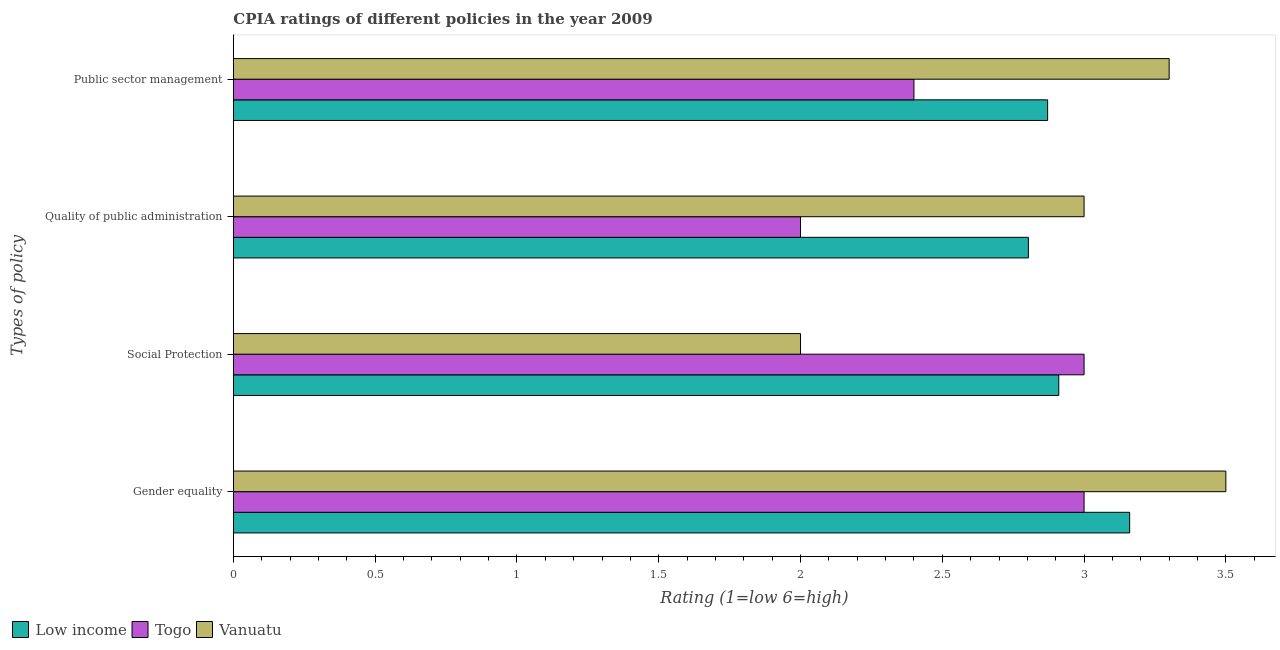How many different coloured bars are there?
Provide a short and direct response. 3. How many groups of bars are there?
Offer a terse response. 4. How many bars are there on the 3rd tick from the top?
Your answer should be very brief. 3. What is the label of the 3rd group of bars from the top?
Your response must be concise. Social Protection. What is the cpia rating of social protection in Vanuatu?
Give a very brief answer. 2. Across all countries, what is the maximum cpia rating of gender equality?
Offer a very short reply. 3.5. Across all countries, what is the minimum cpia rating of public sector management?
Your answer should be compact. 2.4. In which country was the cpia rating of social protection maximum?
Provide a short and direct response. Togo. In which country was the cpia rating of social protection minimum?
Give a very brief answer. Vanuatu. What is the total cpia rating of social protection in the graph?
Provide a short and direct response. 7.91. What is the difference between the cpia rating of gender equality in Low income and that in Togo?
Your answer should be compact. 0.16. What is the difference between the cpia rating of public sector management in Vanuatu and the cpia rating of quality of public administration in Low income?
Give a very brief answer. 0.5. What is the average cpia rating of quality of public administration per country?
Offer a very short reply. 2.6. What is the difference between the cpia rating of quality of public administration and cpia rating of gender equality in Low income?
Make the answer very short. -0.36. What is the ratio of the cpia rating of quality of public administration in Vanuatu to that in Togo?
Offer a very short reply. 1.5. Is the difference between the cpia rating of gender equality in Vanuatu and Low income greater than the difference between the cpia rating of public sector management in Vanuatu and Low income?
Provide a succinct answer. No. What is the difference between the highest and the second highest cpia rating of gender equality?
Your answer should be compact. 0.34. In how many countries, is the cpia rating of public sector management greater than the average cpia rating of public sector management taken over all countries?
Your answer should be compact. 2. What does the 1st bar from the top in Quality of public administration represents?
Offer a very short reply. Vanuatu. What does the 1st bar from the bottom in Public sector management represents?
Ensure brevity in your answer.  Low income. How many bars are there?
Make the answer very short. 12. How many countries are there in the graph?
Your response must be concise. 3. Does the graph contain any zero values?
Offer a terse response. No. How are the legend labels stacked?
Your answer should be compact. Horizontal. What is the title of the graph?
Provide a succinct answer. CPIA ratings of different policies in the year 2009. Does "Turks and Caicos Islands" appear as one of the legend labels in the graph?
Provide a succinct answer. No. What is the label or title of the X-axis?
Keep it short and to the point. Rating (1=low 6=high). What is the label or title of the Y-axis?
Your response must be concise. Types of policy. What is the Rating (1=low 6=high) in Low income in Gender equality?
Your answer should be compact. 3.16. What is the Rating (1=low 6=high) of Vanuatu in Gender equality?
Keep it short and to the point. 3.5. What is the Rating (1=low 6=high) of Low income in Social Protection?
Keep it short and to the point. 2.91. What is the Rating (1=low 6=high) in Togo in Social Protection?
Ensure brevity in your answer.  3. What is the Rating (1=low 6=high) in Low income in Quality of public administration?
Provide a succinct answer. 2.8. What is the Rating (1=low 6=high) of Togo in Quality of public administration?
Give a very brief answer. 2. What is the Rating (1=low 6=high) of Low income in Public sector management?
Keep it short and to the point. 2.87. What is the Rating (1=low 6=high) in Togo in Public sector management?
Offer a terse response. 2.4. Across all Types of policy, what is the maximum Rating (1=low 6=high) in Low income?
Provide a short and direct response. 3.16. Across all Types of policy, what is the maximum Rating (1=low 6=high) of Vanuatu?
Your answer should be very brief. 3.5. Across all Types of policy, what is the minimum Rating (1=low 6=high) in Low income?
Provide a succinct answer. 2.8. Across all Types of policy, what is the minimum Rating (1=low 6=high) in Togo?
Your answer should be very brief. 2. Across all Types of policy, what is the minimum Rating (1=low 6=high) of Vanuatu?
Offer a terse response. 2. What is the total Rating (1=low 6=high) of Low income in the graph?
Your answer should be compact. 11.75. What is the total Rating (1=low 6=high) in Togo in the graph?
Offer a very short reply. 10.4. What is the total Rating (1=low 6=high) in Vanuatu in the graph?
Give a very brief answer. 11.8. What is the difference between the Rating (1=low 6=high) in Low income in Gender equality and that in Social Protection?
Keep it short and to the point. 0.25. What is the difference between the Rating (1=low 6=high) of Low income in Gender equality and that in Quality of public administration?
Give a very brief answer. 0.36. What is the difference between the Rating (1=low 6=high) of Togo in Gender equality and that in Quality of public administration?
Give a very brief answer. 1. What is the difference between the Rating (1=low 6=high) of Vanuatu in Gender equality and that in Quality of public administration?
Your answer should be compact. 0.5. What is the difference between the Rating (1=low 6=high) in Low income in Gender equality and that in Public sector management?
Give a very brief answer. 0.29. What is the difference between the Rating (1=low 6=high) in Togo in Gender equality and that in Public sector management?
Provide a short and direct response. 0.6. What is the difference between the Rating (1=low 6=high) in Vanuatu in Gender equality and that in Public sector management?
Provide a succinct answer. 0.2. What is the difference between the Rating (1=low 6=high) of Low income in Social Protection and that in Quality of public administration?
Your answer should be very brief. 0.11. What is the difference between the Rating (1=low 6=high) of Low income in Social Protection and that in Public sector management?
Your response must be concise. 0.04. What is the difference between the Rating (1=low 6=high) in Togo in Social Protection and that in Public sector management?
Provide a short and direct response. 0.6. What is the difference between the Rating (1=low 6=high) of Vanuatu in Social Protection and that in Public sector management?
Ensure brevity in your answer.  -1.3. What is the difference between the Rating (1=low 6=high) of Low income in Quality of public administration and that in Public sector management?
Make the answer very short. -0.07. What is the difference between the Rating (1=low 6=high) in Togo in Quality of public administration and that in Public sector management?
Ensure brevity in your answer.  -0.4. What is the difference between the Rating (1=low 6=high) in Low income in Gender equality and the Rating (1=low 6=high) in Togo in Social Protection?
Offer a terse response. 0.16. What is the difference between the Rating (1=low 6=high) of Low income in Gender equality and the Rating (1=low 6=high) of Vanuatu in Social Protection?
Provide a short and direct response. 1.16. What is the difference between the Rating (1=low 6=high) in Low income in Gender equality and the Rating (1=low 6=high) in Togo in Quality of public administration?
Offer a very short reply. 1.16. What is the difference between the Rating (1=low 6=high) in Low income in Gender equality and the Rating (1=low 6=high) in Vanuatu in Quality of public administration?
Provide a succinct answer. 0.16. What is the difference between the Rating (1=low 6=high) in Low income in Gender equality and the Rating (1=low 6=high) in Togo in Public sector management?
Your answer should be compact. 0.76. What is the difference between the Rating (1=low 6=high) of Low income in Gender equality and the Rating (1=low 6=high) of Vanuatu in Public sector management?
Make the answer very short. -0.14. What is the difference between the Rating (1=low 6=high) in Low income in Social Protection and the Rating (1=low 6=high) in Togo in Quality of public administration?
Provide a succinct answer. 0.91. What is the difference between the Rating (1=low 6=high) in Low income in Social Protection and the Rating (1=low 6=high) in Vanuatu in Quality of public administration?
Provide a short and direct response. -0.09. What is the difference between the Rating (1=low 6=high) in Togo in Social Protection and the Rating (1=low 6=high) in Vanuatu in Quality of public administration?
Ensure brevity in your answer.  0. What is the difference between the Rating (1=low 6=high) in Low income in Social Protection and the Rating (1=low 6=high) in Togo in Public sector management?
Keep it short and to the point. 0.51. What is the difference between the Rating (1=low 6=high) in Low income in Social Protection and the Rating (1=low 6=high) in Vanuatu in Public sector management?
Your response must be concise. -0.39. What is the difference between the Rating (1=low 6=high) in Low income in Quality of public administration and the Rating (1=low 6=high) in Togo in Public sector management?
Offer a very short reply. 0.4. What is the difference between the Rating (1=low 6=high) in Low income in Quality of public administration and the Rating (1=low 6=high) in Vanuatu in Public sector management?
Give a very brief answer. -0.5. What is the difference between the Rating (1=low 6=high) of Togo in Quality of public administration and the Rating (1=low 6=high) of Vanuatu in Public sector management?
Provide a short and direct response. -1.3. What is the average Rating (1=low 6=high) in Low income per Types of policy?
Keep it short and to the point. 2.94. What is the average Rating (1=low 6=high) in Togo per Types of policy?
Your answer should be very brief. 2.6. What is the average Rating (1=low 6=high) of Vanuatu per Types of policy?
Provide a short and direct response. 2.95. What is the difference between the Rating (1=low 6=high) in Low income and Rating (1=low 6=high) in Togo in Gender equality?
Give a very brief answer. 0.16. What is the difference between the Rating (1=low 6=high) of Low income and Rating (1=low 6=high) of Vanuatu in Gender equality?
Ensure brevity in your answer.  -0.34. What is the difference between the Rating (1=low 6=high) of Low income and Rating (1=low 6=high) of Togo in Social Protection?
Your answer should be compact. -0.09. What is the difference between the Rating (1=low 6=high) in Low income and Rating (1=low 6=high) in Vanuatu in Social Protection?
Keep it short and to the point. 0.91. What is the difference between the Rating (1=low 6=high) in Togo and Rating (1=low 6=high) in Vanuatu in Social Protection?
Provide a short and direct response. 1. What is the difference between the Rating (1=low 6=high) in Low income and Rating (1=low 6=high) in Togo in Quality of public administration?
Offer a terse response. 0.8. What is the difference between the Rating (1=low 6=high) in Low income and Rating (1=low 6=high) in Vanuatu in Quality of public administration?
Ensure brevity in your answer.  -0.2. What is the difference between the Rating (1=low 6=high) of Togo and Rating (1=low 6=high) of Vanuatu in Quality of public administration?
Ensure brevity in your answer.  -1. What is the difference between the Rating (1=low 6=high) in Low income and Rating (1=low 6=high) in Togo in Public sector management?
Offer a very short reply. 0.47. What is the difference between the Rating (1=low 6=high) of Low income and Rating (1=low 6=high) of Vanuatu in Public sector management?
Provide a short and direct response. -0.43. What is the ratio of the Rating (1=low 6=high) in Low income in Gender equality to that in Social Protection?
Ensure brevity in your answer.  1.09. What is the ratio of the Rating (1=low 6=high) in Togo in Gender equality to that in Social Protection?
Offer a very short reply. 1. What is the ratio of the Rating (1=low 6=high) of Vanuatu in Gender equality to that in Social Protection?
Your answer should be compact. 1.75. What is the ratio of the Rating (1=low 6=high) of Low income in Gender equality to that in Quality of public administration?
Your response must be concise. 1.13. What is the ratio of the Rating (1=low 6=high) in Vanuatu in Gender equality to that in Quality of public administration?
Offer a terse response. 1.17. What is the ratio of the Rating (1=low 6=high) of Low income in Gender equality to that in Public sector management?
Give a very brief answer. 1.1. What is the ratio of the Rating (1=low 6=high) in Togo in Gender equality to that in Public sector management?
Your response must be concise. 1.25. What is the ratio of the Rating (1=low 6=high) of Vanuatu in Gender equality to that in Public sector management?
Your response must be concise. 1.06. What is the ratio of the Rating (1=low 6=high) of Low income in Social Protection to that in Quality of public administration?
Give a very brief answer. 1.04. What is the ratio of the Rating (1=low 6=high) of Low income in Social Protection to that in Public sector management?
Ensure brevity in your answer.  1.01. What is the ratio of the Rating (1=low 6=high) of Vanuatu in Social Protection to that in Public sector management?
Offer a terse response. 0.61. What is the ratio of the Rating (1=low 6=high) of Low income in Quality of public administration to that in Public sector management?
Offer a terse response. 0.98. What is the ratio of the Rating (1=low 6=high) of Togo in Quality of public administration to that in Public sector management?
Your answer should be compact. 0.83. What is the difference between the highest and the second highest Rating (1=low 6=high) of Low income?
Keep it short and to the point. 0.25. What is the difference between the highest and the second highest Rating (1=low 6=high) in Togo?
Your answer should be very brief. 0. What is the difference between the highest and the second highest Rating (1=low 6=high) of Vanuatu?
Provide a short and direct response. 0.2. What is the difference between the highest and the lowest Rating (1=low 6=high) of Low income?
Offer a very short reply. 0.36. 